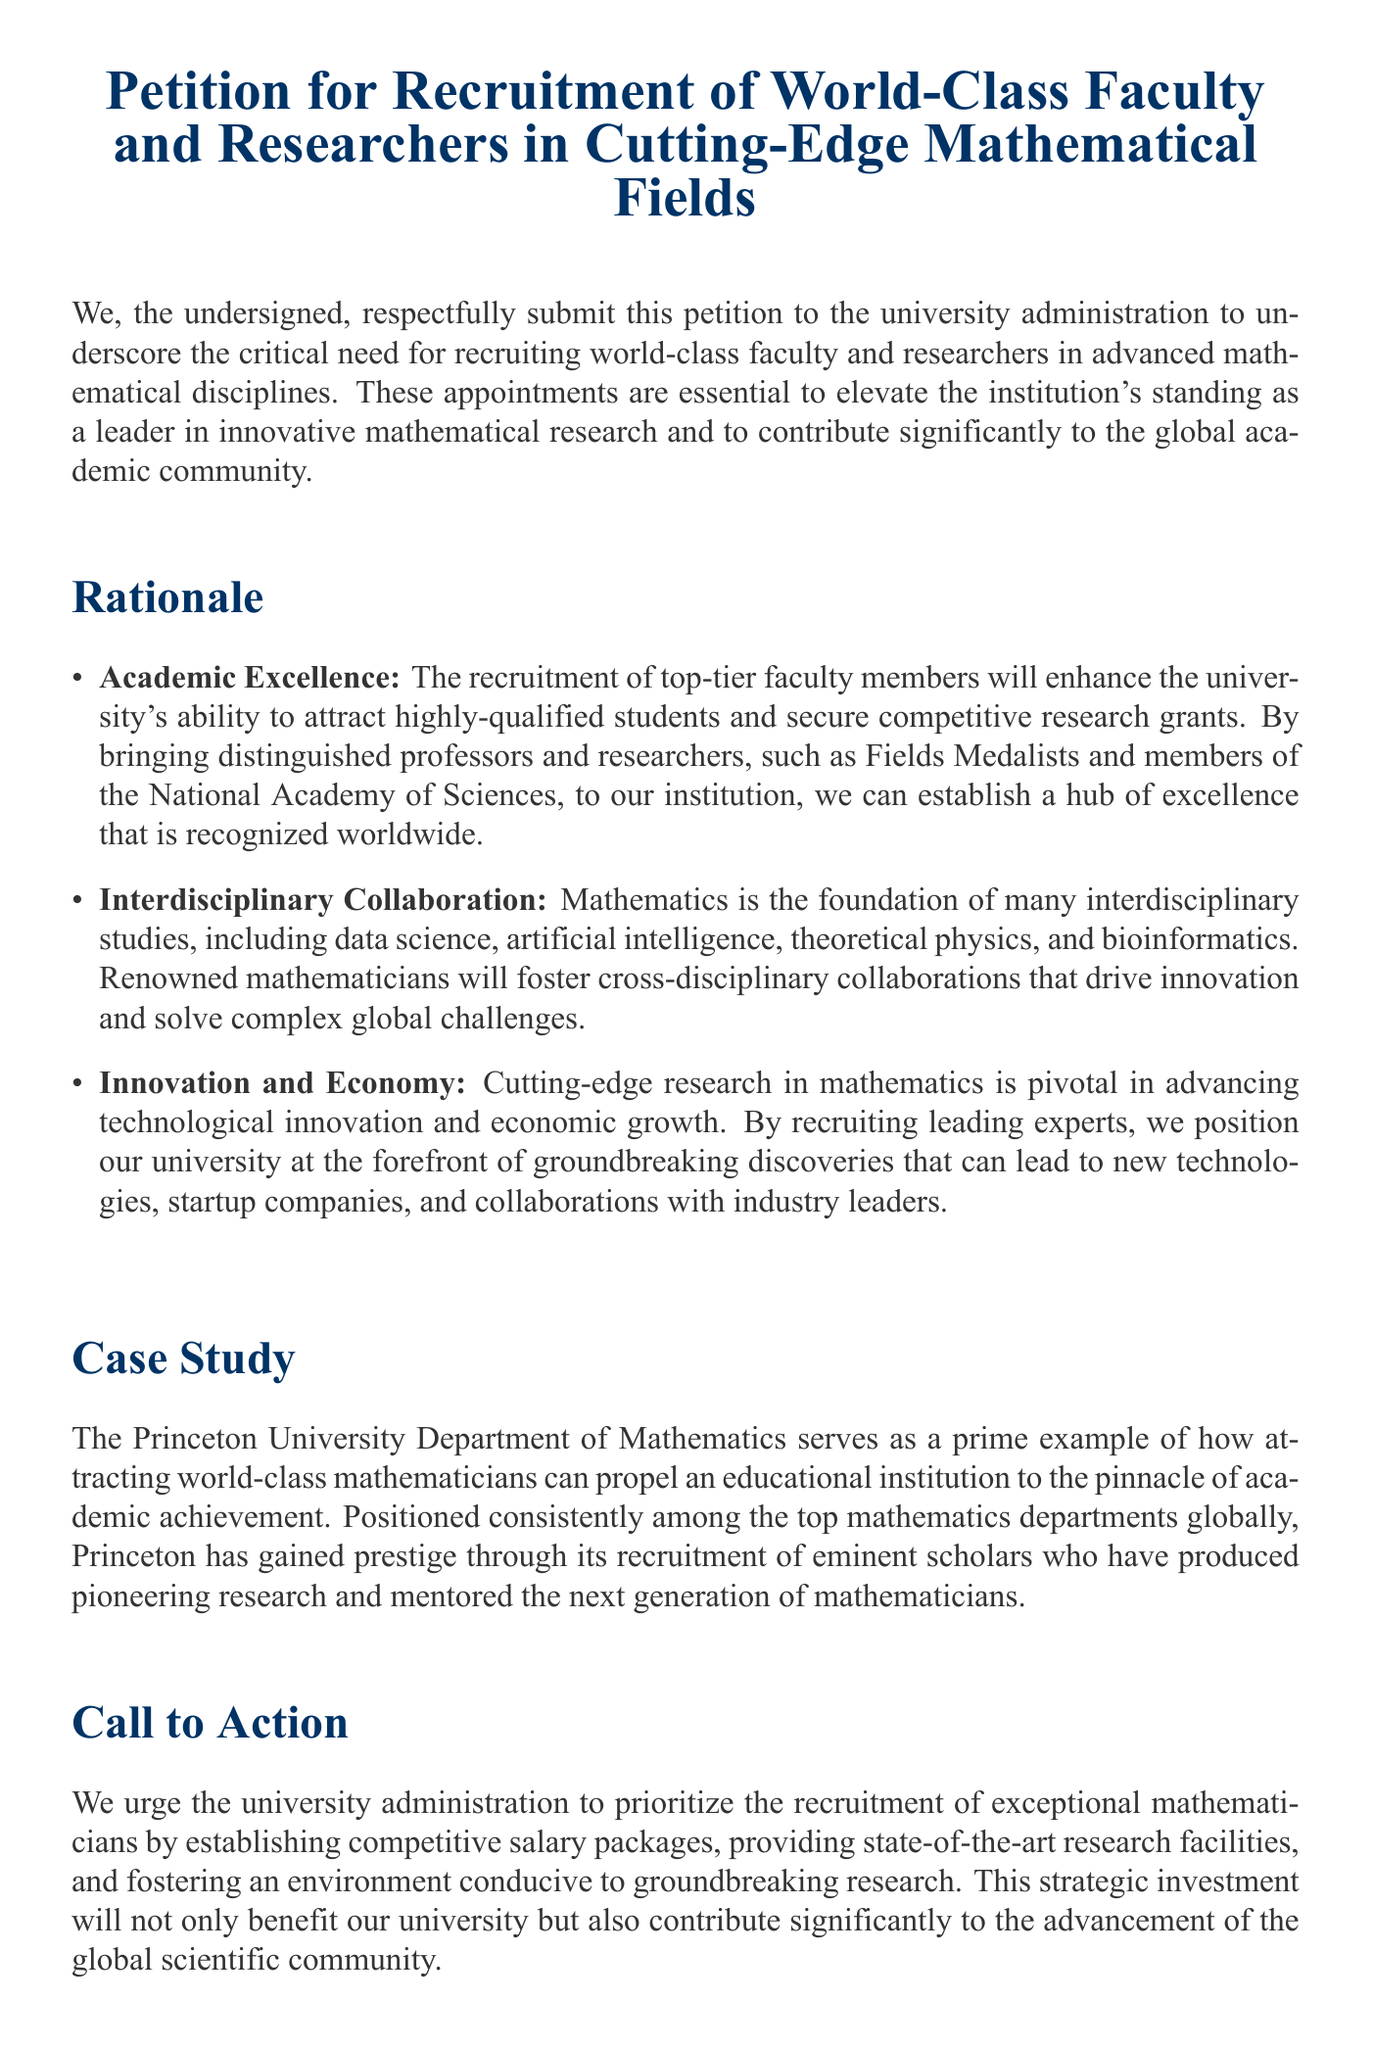What is the title of the petition? The title of the petition is prominently displayed at the top of the document.
Answer: Petition for Recruitment of World-Class Faculty and Researchers in Cutting-Edge Mathematical Fields Who is the first signatory of the petition? The first signatory is listed in the "Signatories" section of the document.
Answer: Dr. Alice Smith What is one of the reasons for recruiting top-tier faculty? The reasons are listed in the "Rationale" section and provide specific benefits of recruitment.
Answer: Academic Excellence Which university is mentioned as a case study? The case study provides an example of a successful department related to recruitment.
Answer: Princeton University What does the petition urge the university administration to establish? The "Call to Action" section outlines what is necessary for effective recruitment.
Answer: Competitive salary packages How many signatories are listed in total? Counting the names in the "Signatories" section provides the total.
Answer: Four What field does Dr. John Doe belong to? The signatories list specifies each person's academic department.
Answer: Computer Science What term is used to describe the recruitment strategy mentioned in the petition? The petition emphasizes the importance of a strategic approach to recruitment.
Answer: Strategic investment 